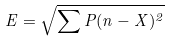Convert formula to latex. <formula><loc_0><loc_0><loc_500><loc_500>E = \sqrt { \sum P ( n - X ) ^ { 2 } }</formula> 